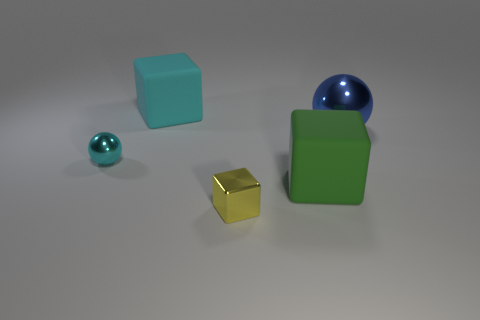Add 1 large metallic spheres. How many objects exist? 6 Subtract all spheres. How many objects are left? 3 Add 3 matte blocks. How many matte blocks are left? 5 Add 4 yellow metal cubes. How many yellow metal cubes exist? 5 Subtract 0 blue cylinders. How many objects are left? 5 Subtract all big cyan matte objects. Subtract all blue spheres. How many objects are left? 3 